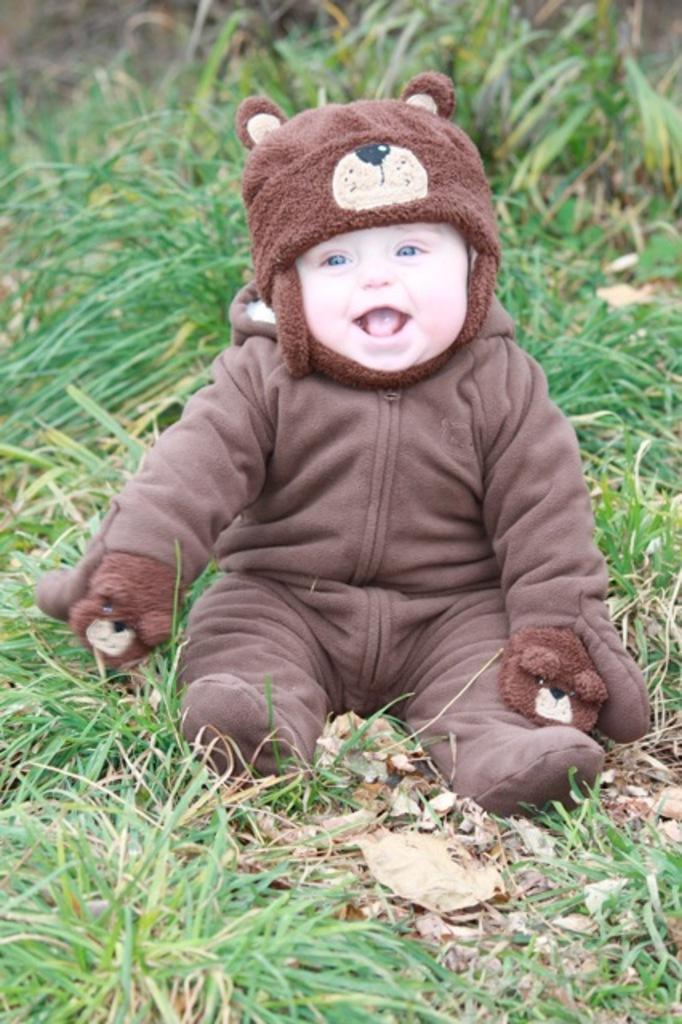What is the main subject of the image? There is a child in the image. What is the child wearing? The child is wearing a brown dress. Where is the child sitting? The child is sitting on the ground. What type of vegetation can be seen on the ground? There are leaves and grass on the ground. What time does the clock show in the image? There is no clock present in the image. Can you tell me what animals are visible in the zoo in the image? There is no zoo or animals visible in the image; it features a child sitting on the ground with leaves and grass around them. 